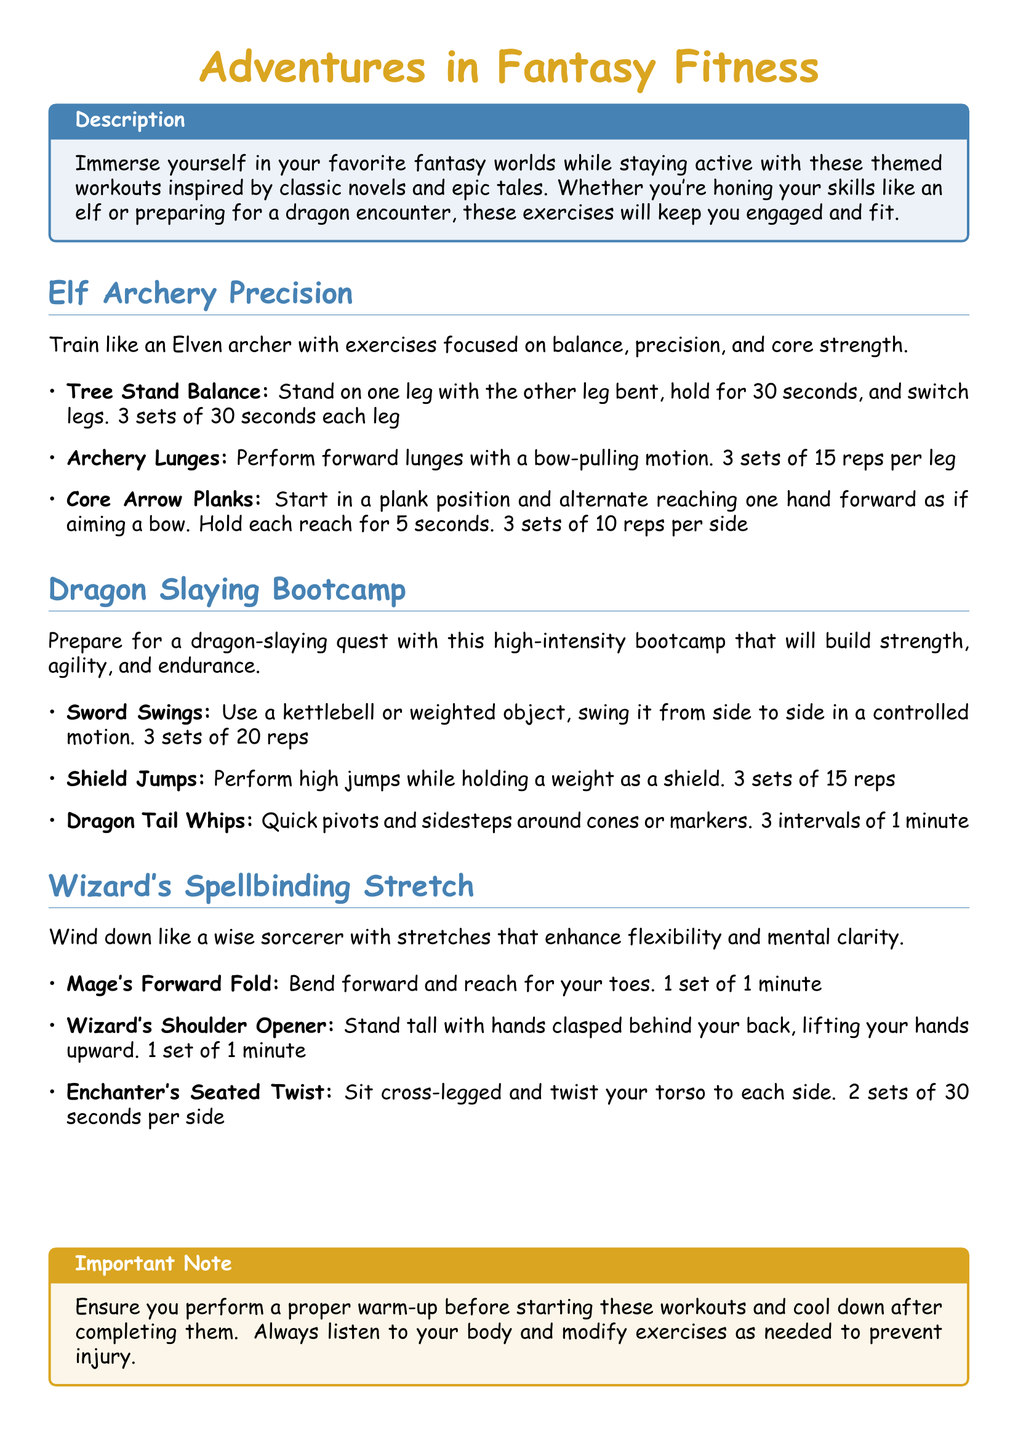What is the title of the workout plan? The title of the workout plan is stated at the top of the document.
Answer: Adventures in Fantasy Fitness What is the first exercise listed under Elf Archery Precision? The first exercise listed under Elf Archery Precision is explicitly mentioned in the document.
Answer: Tree Stand Balance How many sets are recommended for Archery Lunges? The recommended number of sets for Archery Lunges is provided in the workout plan.
Answer: 3 sets What type of jumps are included in the Dragon Slaying Bootcamp? The type of jumps listed in the document can be identified in the Dragon Slaying Bootcamp section.
Answer: Shield Jumps What exercise involves reaching for your toes? This exercise is mentioned in the stretch section for winding down.
Answer: Mage's Forward Fold How long should one hold the Tree Stand Balance exercise? The duration for holding the Tree Stand Balance is specified in the workout plan.
Answer: 30 seconds What is the total number of exercises listed under Wizard's Spellbinding Stretch? The document lists the number of exercises included in the Wizard's Spellbinding Stretch section.
Answer: 3 exercises What equipment is suggested for Sword Swings? The type of equipment recommended for Sword Swings is mentioned directly.
Answer: Kettlebell What should you ensure before starting the workouts? The important precaution before starting workouts is stated clearly in the document.
Answer: Proper warm-up 